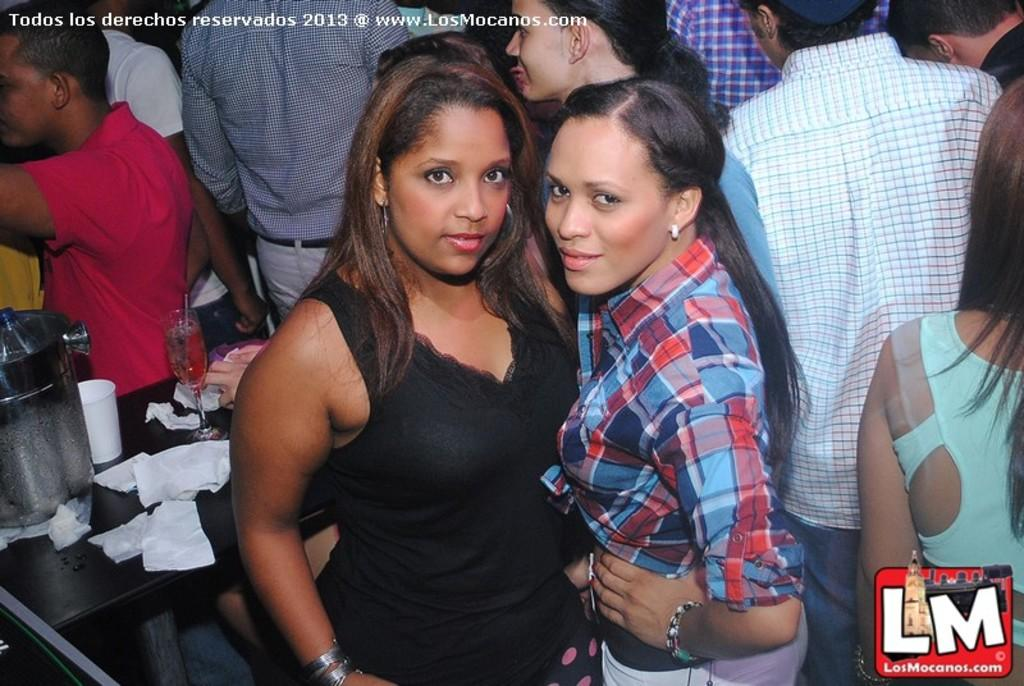What is happening in the image? There is a group of people standing in the image. Where is the table located in the image? The table is on the left side of the image. What can be seen on the table? There are glasses and tissue papers on the table, along with other objects. What type of meal is being served on the table in the image? There is no meal visible on the table in the image. Can you see a chessboard on the table in the image? There is no chessboard present on the table in the image. 